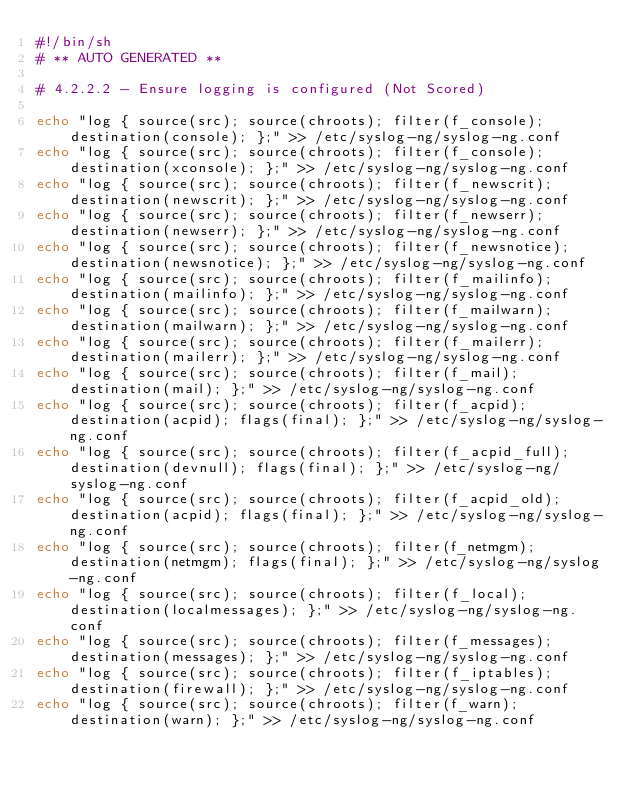<code> <loc_0><loc_0><loc_500><loc_500><_Bash_>#!/bin/sh
# ** AUTO GENERATED **

# 4.2.2.2 - Ensure logging is configured (Not Scored)

echo "log { source(src); source(chroots); filter(f_console); destination(console); };" >> /etc/syslog-ng/syslog-ng.conf
echo "log { source(src); source(chroots); filter(f_console); destination(xconsole); };" >> /etc/syslog-ng/syslog-ng.conf
echo "log { source(src); source(chroots); filter(f_newscrit); destination(newscrit); };" >> /etc/syslog-ng/syslog-ng.conf
echo "log { source(src); source(chroots); filter(f_newserr); destination(newserr); };" >> /etc/syslog-ng/syslog-ng.conf
echo "log { source(src); source(chroots); filter(f_newsnotice); destination(newsnotice); };" >> /etc/syslog-ng/syslog-ng.conf
echo "log { source(src); source(chroots); filter(f_mailinfo); destination(mailinfo); };" >> /etc/syslog-ng/syslog-ng.conf
echo "log { source(src); source(chroots); filter(f_mailwarn); destination(mailwarn); };" >> /etc/syslog-ng/syslog-ng.conf
echo "log { source(src); source(chroots); filter(f_mailerr); destination(mailerr); };" >> /etc/syslog-ng/syslog-ng.conf
echo "log { source(src); source(chroots); filter(f_mail); destination(mail); };" >> /etc/syslog-ng/syslog-ng.conf
echo "log { source(src); source(chroots); filter(f_acpid); destination(acpid); flags(final); };" >> /etc/syslog-ng/syslog-ng.conf
echo "log { source(src); source(chroots); filter(f_acpid_full); destination(devnull); flags(final); };" >> /etc/syslog-ng/syslog-ng.conf
echo "log { source(src); source(chroots); filter(f_acpid_old); destination(acpid); flags(final); };" >> /etc/syslog-ng/syslog-ng.conf
echo "log { source(src); source(chroots); filter(f_netmgm); destination(netmgm); flags(final); };" >> /etc/syslog-ng/syslog-ng.conf
echo "log { source(src); source(chroots); filter(f_local); destination(localmessages); };" >> /etc/syslog-ng/syslog-ng.conf
echo "log { source(src); source(chroots); filter(f_messages); destination(messages); };" >> /etc/syslog-ng/syslog-ng.conf
echo "log { source(src); source(chroots); filter(f_iptables); destination(firewall); };" >> /etc/syslog-ng/syslog-ng.conf
echo "log { source(src); source(chroots); filter(f_warn); destination(warn); };" >> /etc/syslog-ng/syslog-ng.conf

</code> 